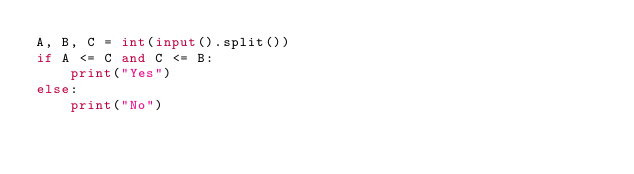Convert code to text. <code><loc_0><loc_0><loc_500><loc_500><_Python_>A, B, C = int(input().split())
if A <= C and C <= B:
    print("Yes")
else:
    print("No")
</code> 